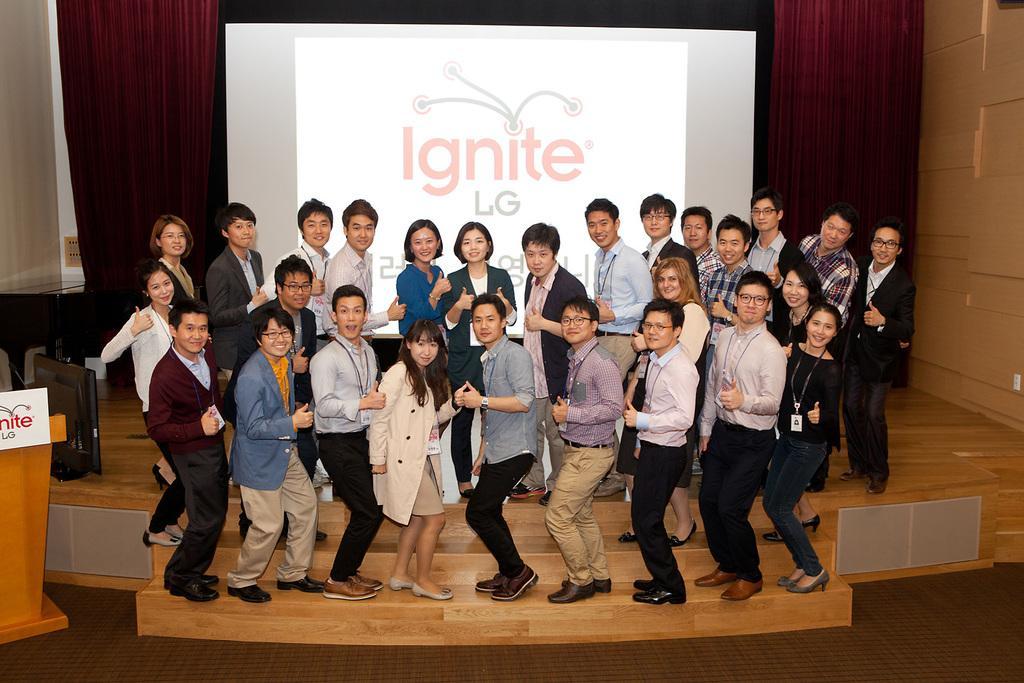Could you give a brief overview of what you see in this image? In this image I can see the group of people with different color dresses. To the left I can see the podium and the screen. In the background I can see the screen and there is a black, maroon and cream color background. 